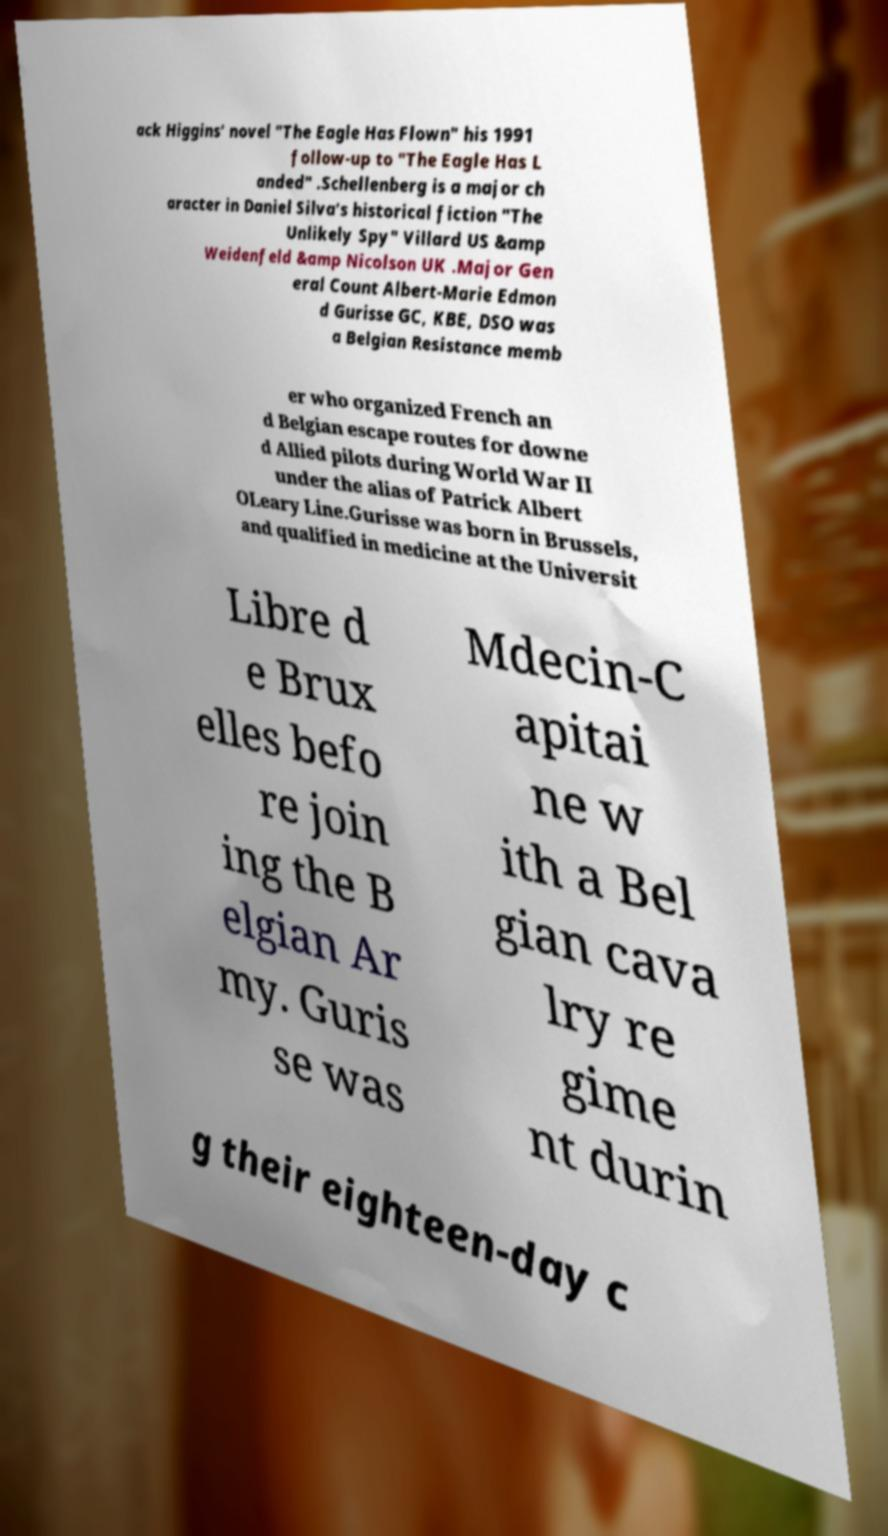For documentation purposes, I need the text within this image transcribed. Could you provide that? ack Higgins' novel "The Eagle Has Flown" his 1991 follow-up to "The Eagle Has L anded" .Schellenberg is a major ch aracter in Daniel Silva's historical fiction "The Unlikely Spy" Villard US &amp Weidenfeld &amp Nicolson UK .Major Gen eral Count Albert-Marie Edmon d Gurisse GC, KBE, DSO was a Belgian Resistance memb er who organized French an d Belgian escape routes for downe d Allied pilots during World War II under the alias of Patrick Albert OLeary Line.Gurisse was born in Brussels, and qualified in medicine at the Universit Libre d e Brux elles befo re join ing the B elgian Ar my. Guris se was Mdecin-C apitai ne w ith a Bel gian cava lry re gime nt durin g their eighteen-day c 